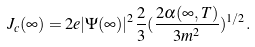<formula> <loc_0><loc_0><loc_500><loc_500>J _ { c } ( \infty ) = 2 e | \Psi ( \infty ) | ^ { 2 } \frac { 2 } { 3 } ( \frac { 2 \alpha ( \infty , T ) } { 3 m ^ { 2 } } ) ^ { 1 / 2 } .</formula> 